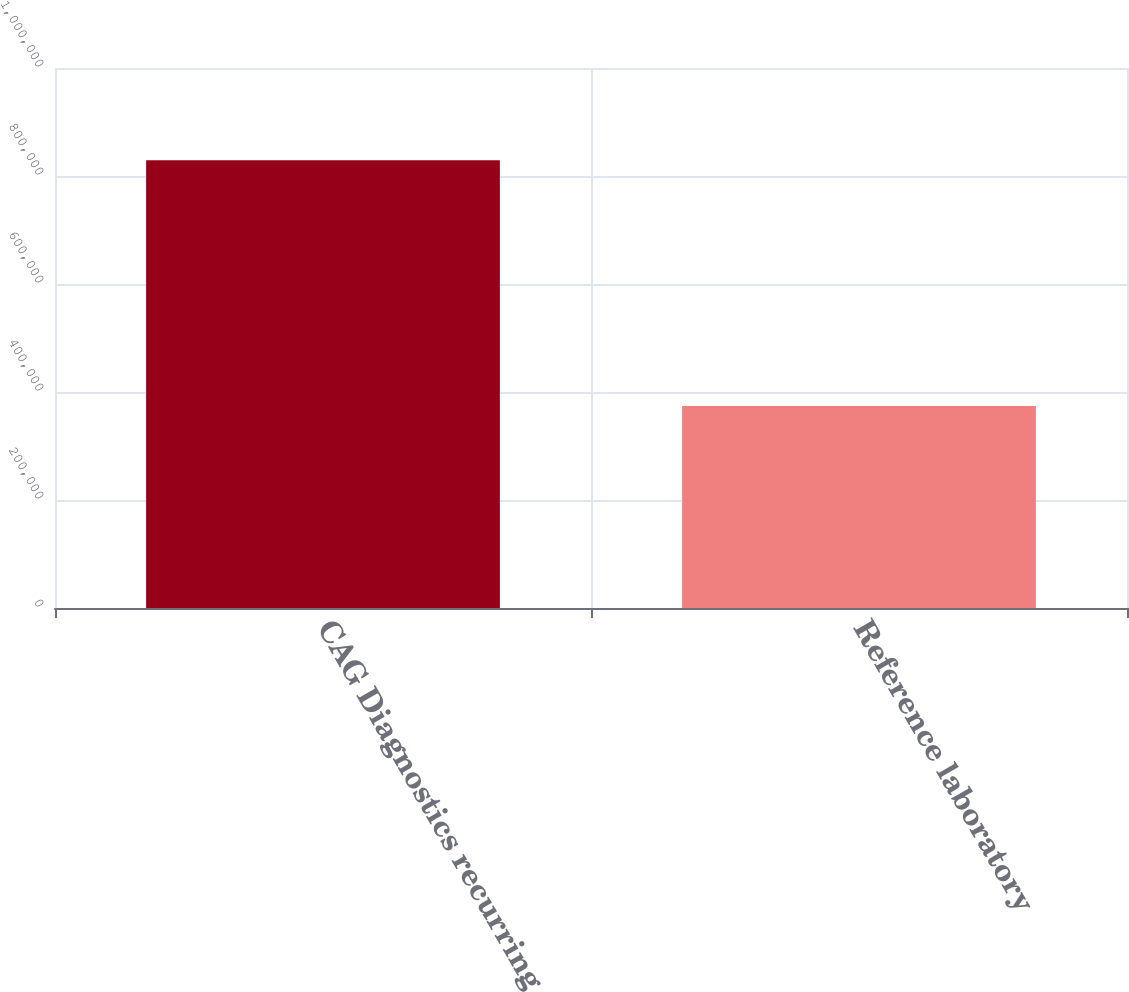<chart> <loc_0><loc_0><loc_500><loc_500><bar_chart><fcel>CAG Diagnostics recurring<fcel>Reference laboratory<nl><fcel>829192<fcel>373919<nl></chart> 